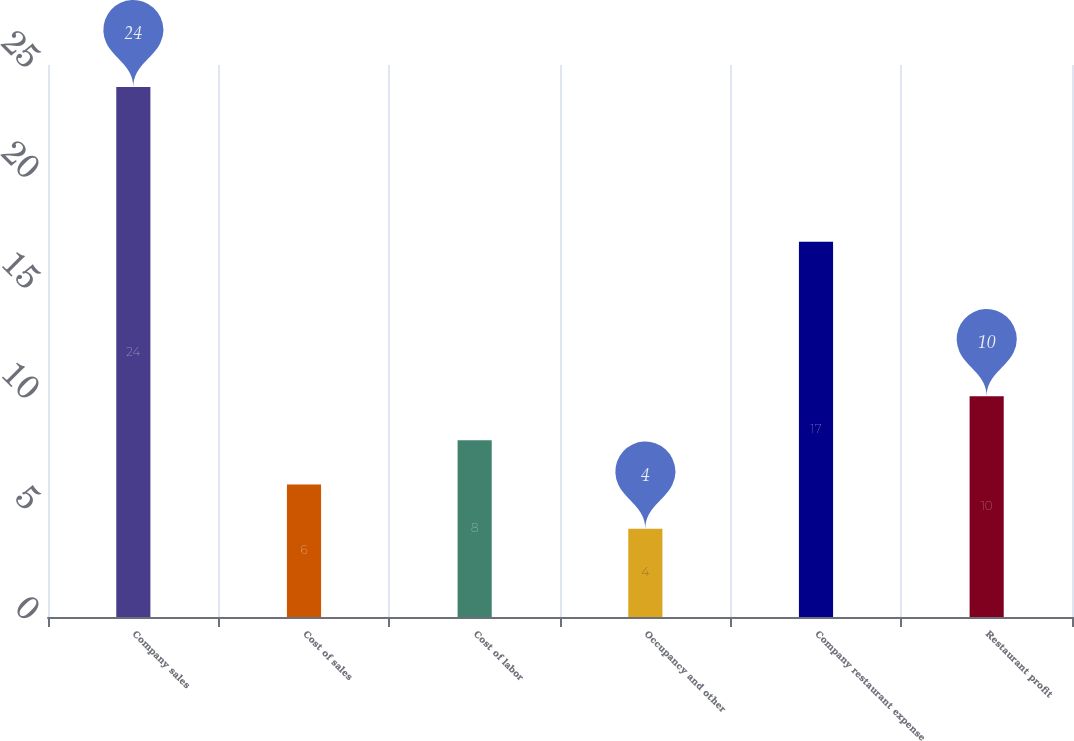Convert chart to OTSL. <chart><loc_0><loc_0><loc_500><loc_500><bar_chart><fcel>Company sales<fcel>Cost of sales<fcel>Cost of labor<fcel>Occupancy and other<fcel>Company restaurant expense<fcel>Restaurant profit<nl><fcel>24<fcel>6<fcel>8<fcel>4<fcel>17<fcel>10<nl></chart> 